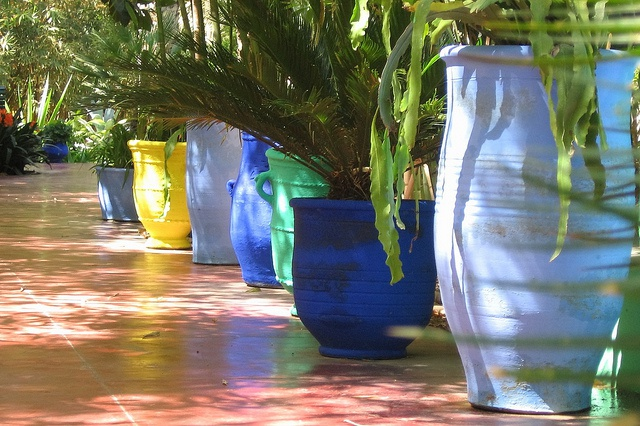Describe the objects in this image and their specific colors. I can see potted plant in olive, gray, and darkgray tones, vase in olive, gray, and white tones, potted plant in olive, black, navy, and darkgreen tones, potted plant in olive, gold, beige, and khaki tones, and vase in olive, gray, and darkgray tones in this image. 